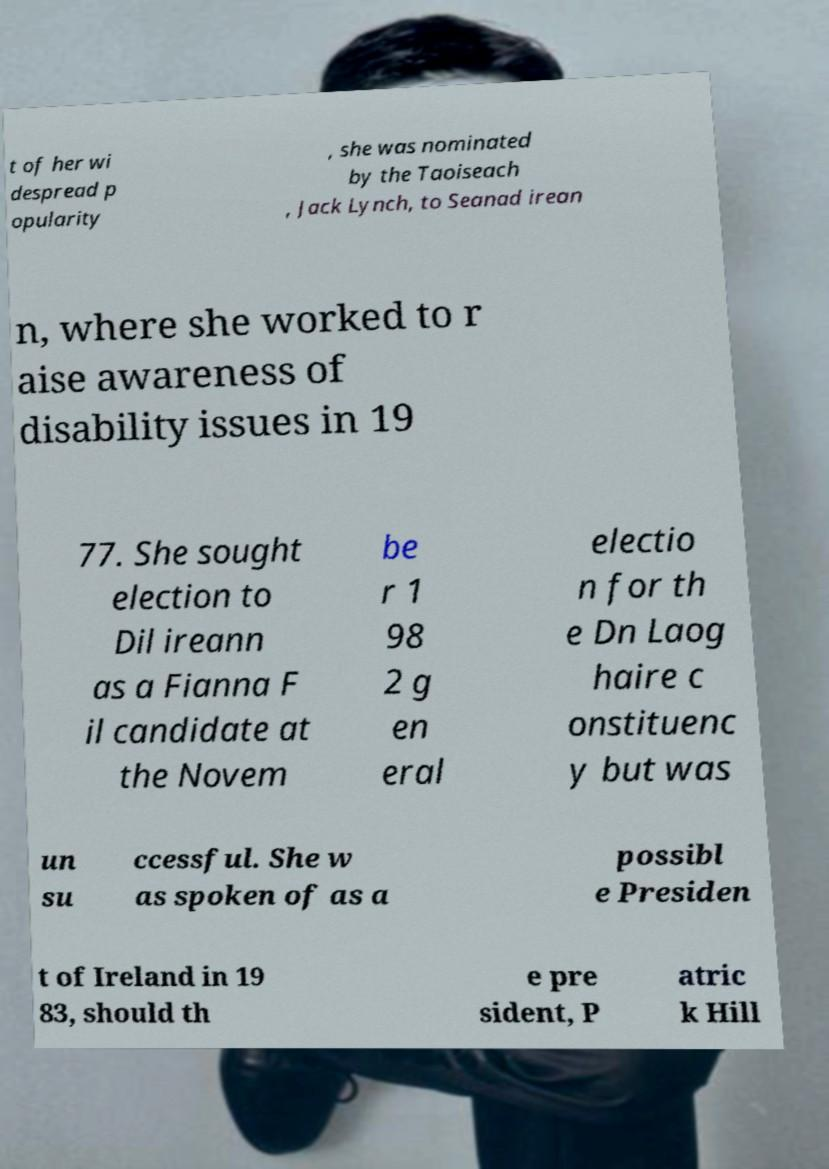Could you assist in decoding the text presented in this image and type it out clearly? t of her wi despread p opularity , she was nominated by the Taoiseach , Jack Lynch, to Seanad irean n, where she worked to r aise awareness of disability issues in 19 77. She sought election to Dil ireann as a Fianna F il candidate at the Novem be r 1 98 2 g en eral electio n for th e Dn Laog haire c onstituenc y but was un su ccessful. She w as spoken of as a possibl e Presiden t of Ireland in 19 83, should th e pre sident, P atric k Hill 